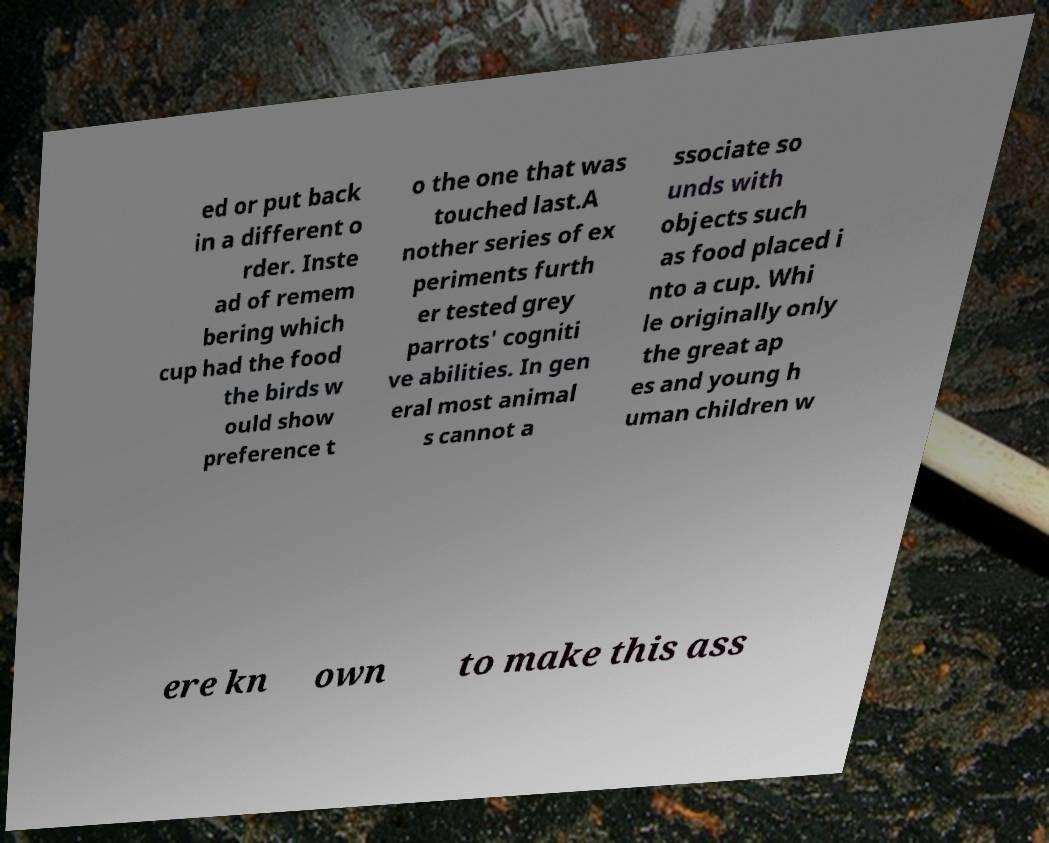I need the written content from this picture converted into text. Can you do that? ed or put back in a different o rder. Inste ad of remem bering which cup had the food the birds w ould show preference t o the one that was touched last.A nother series of ex periments furth er tested grey parrots' cogniti ve abilities. In gen eral most animal s cannot a ssociate so unds with objects such as food placed i nto a cup. Whi le originally only the great ap es and young h uman children w ere kn own to make this ass 